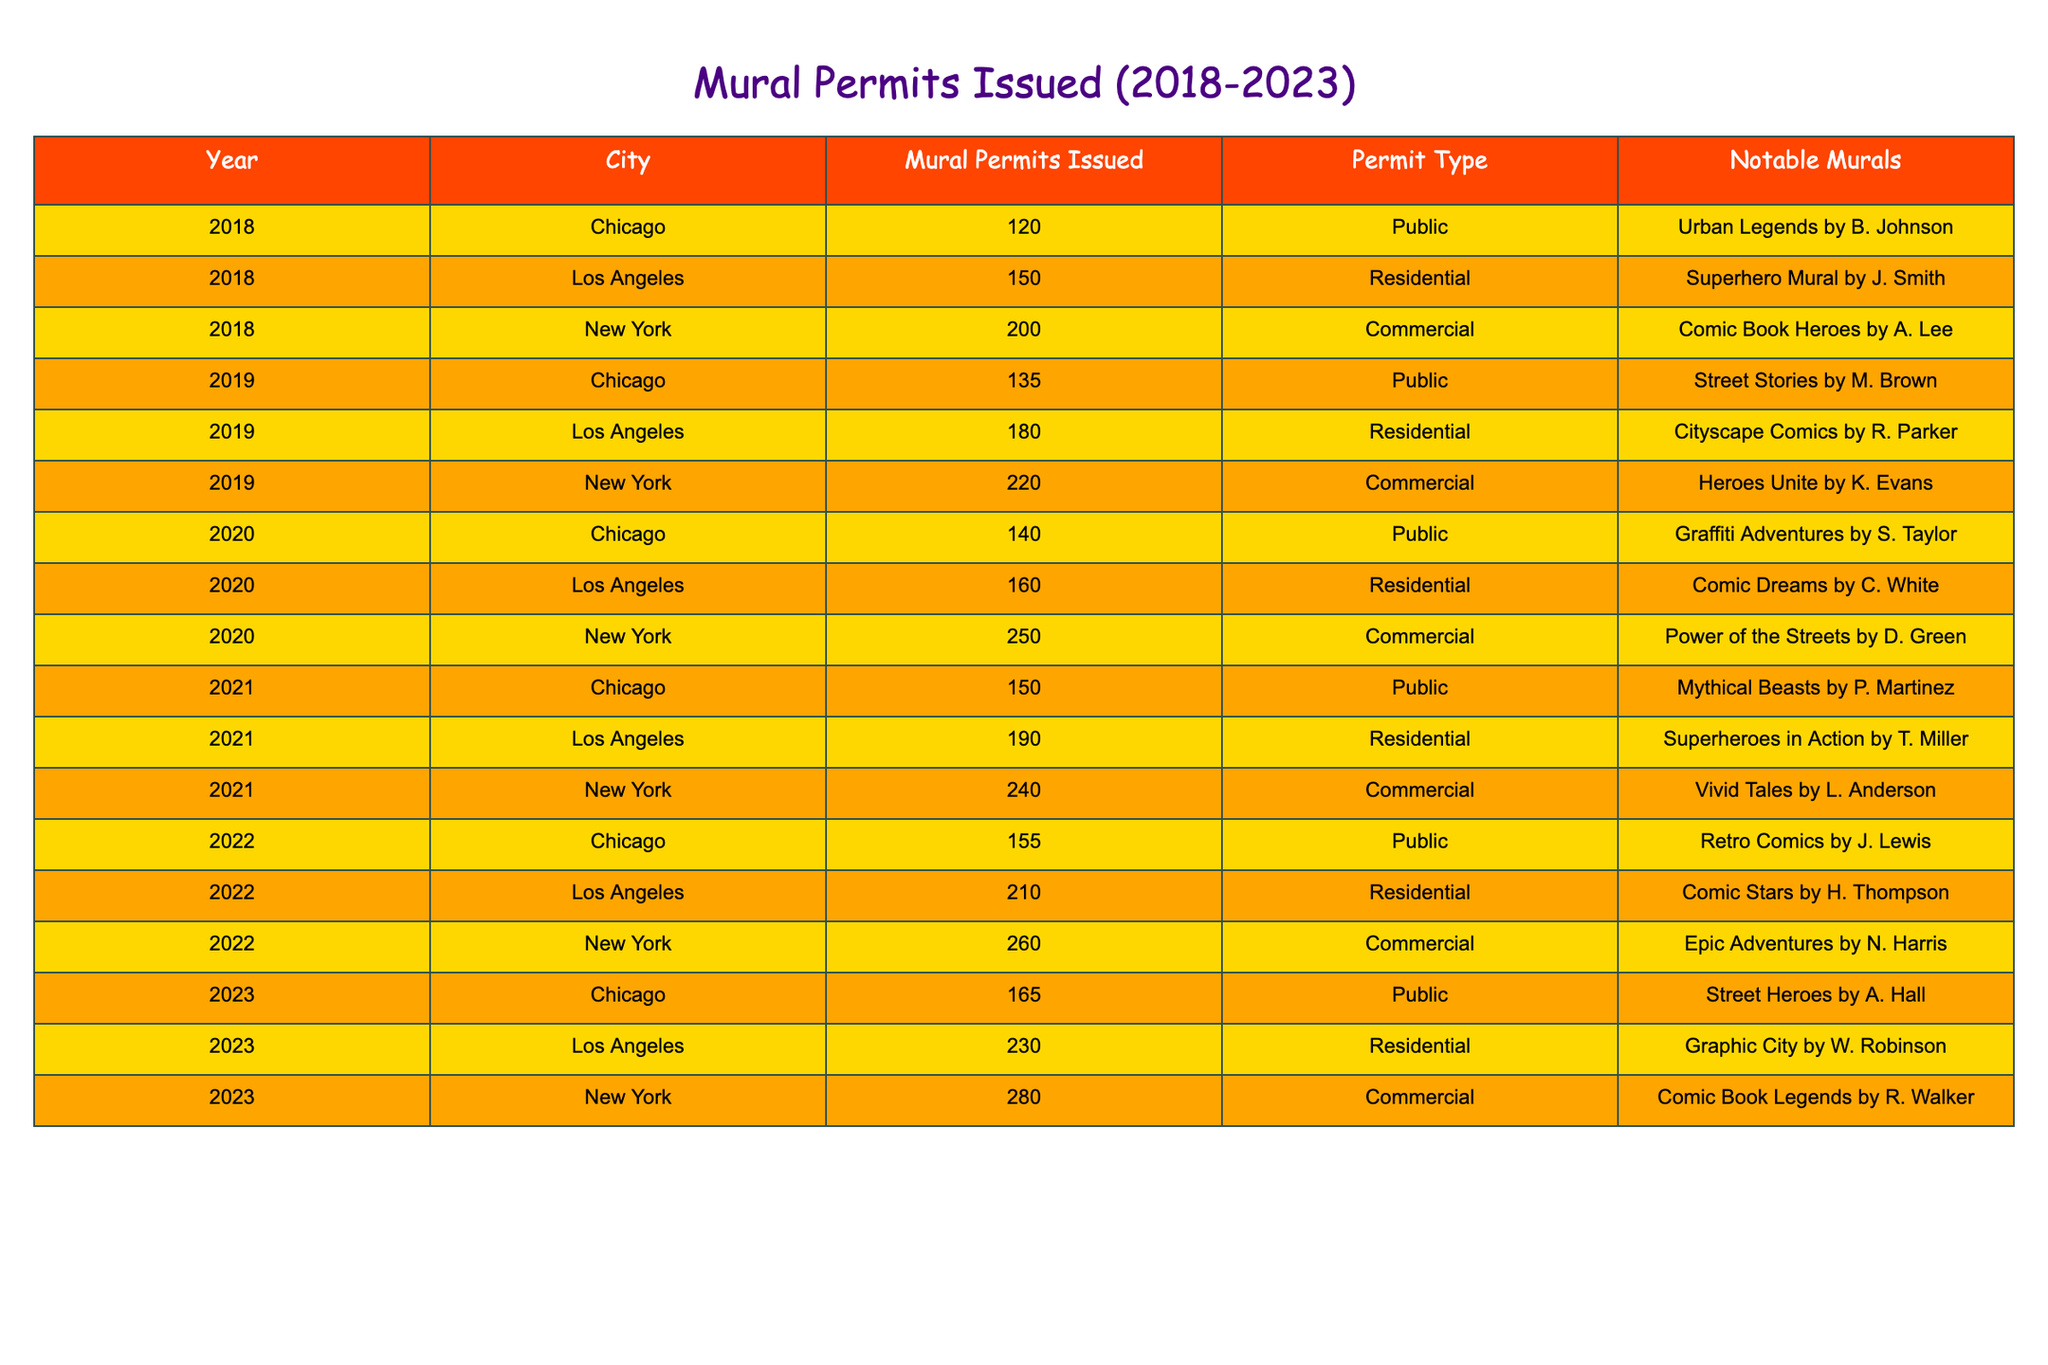What city issued the most mural permits in 2022? From the table, we can look at the "Mural Permits Issued" column specifically for the year 2022. The values indicate that Los Angeles issued 210 permits, New York issued 260 permits, and Chicago issued 155 permits. Therefore, New York, with 260 permits, had the highest number.
Answer: New York How many mural permits were issued in total across all cities in 2021? To find the total permits issued in 2021, we sum the values for each city in that year. Los Angeles had 190 permits, New York had 240 permits, and Chicago had 150 permits. Adding these together: 190 + 240 + 150 = 580 permits in total.
Answer: 580 Did Chicago ever issue more mural permits than Los Angeles from 2018 to 2023? In the table data, we need to compare the annual permits issued by Chicago and Los Angeles. Reviewing the data, the number of permits issued by Chicago was less than that of Los Angeles in every year from 2018 to 2023. Therefore, the statement is false.
Answer: No What was the average number of mural permits issued by New York from 2018 to 2023? To calculate the average for New York, we sum the permits issued over all years: 200 (2018) + 220 (2019) + 250 (2020) + 240 (2021) + 260 (2022) + 280 (2023) = 1450. There are 6 years, so we divide the sum by 6, which gives us 1450 / 6 = approximately 241.67.
Answer: 241.67 In which year did Los Angeles see its highest number of mural permits issued? Checking the values in the "Mural Permits Issued" column for Los Angeles: 150 (2018), 180 (2019), 160 (2020), 190 (2021), 210 (2022), and 230 (2023). The highest number recorded is 230 permits in 2023.
Answer: 2023 